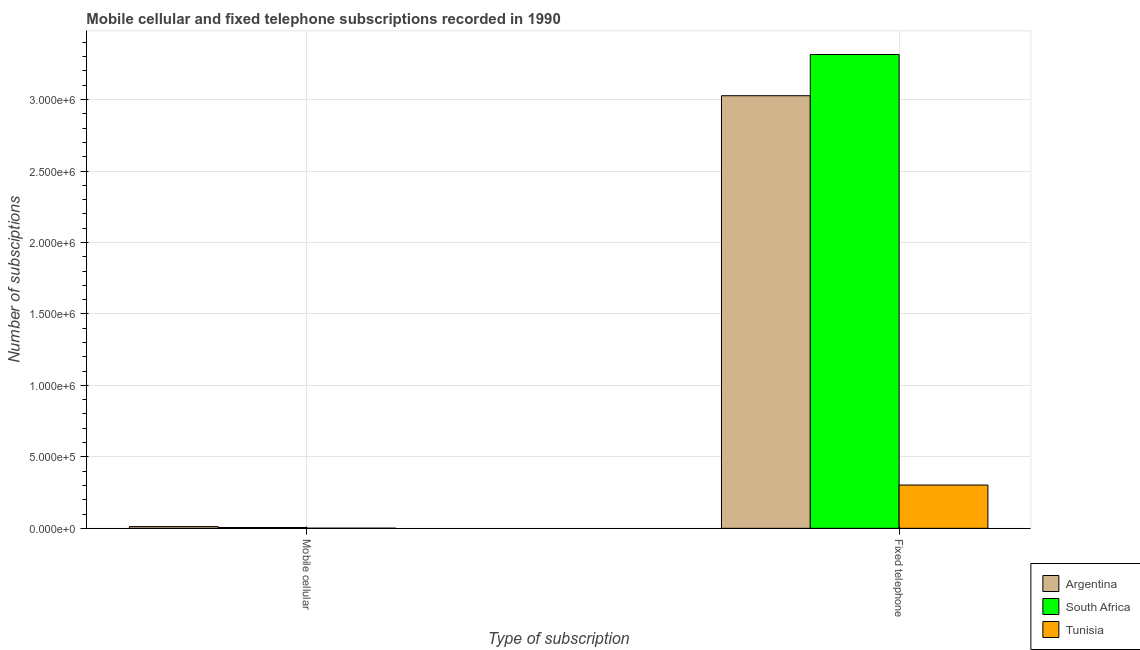How many groups of bars are there?
Provide a short and direct response. 2. How many bars are there on the 2nd tick from the right?
Give a very brief answer. 3. What is the label of the 1st group of bars from the left?
Offer a very short reply. Mobile cellular. What is the number of fixed telephone subscriptions in South Africa?
Offer a terse response. 3.32e+06. Across all countries, what is the maximum number of mobile cellular subscriptions?
Ensure brevity in your answer.  1.20e+04. Across all countries, what is the minimum number of fixed telephone subscriptions?
Provide a short and direct response. 3.03e+05. In which country was the number of mobile cellular subscriptions maximum?
Your answer should be very brief. Argentina. In which country was the number of mobile cellular subscriptions minimum?
Keep it short and to the point. Tunisia. What is the total number of fixed telephone subscriptions in the graph?
Make the answer very short. 6.64e+06. What is the difference between the number of fixed telephone subscriptions in Tunisia and that in South Africa?
Offer a terse response. -3.01e+06. What is the difference between the number of fixed telephone subscriptions in Argentina and the number of mobile cellular subscriptions in Tunisia?
Offer a very short reply. 3.03e+06. What is the average number of fixed telephone subscriptions per country?
Ensure brevity in your answer.  2.21e+06. What is the difference between the number of fixed telephone subscriptions and number of mobile cellular subscriptions in Argentina?
Ensure brevity in your answer.  3.01e+06. In how many countries, is the number of mobile cellular subscriptions greater than 700000 ?
Keep it short and to the point. 0. What is the ratio of the number of fixed telephone subscriptions in South Africa to that in Argentina?
Offer a very short reply. 1.1. Is the number of mobile cellular subscriptions in Tunisia less than that in South Africa?
Your answer should be very brief. Yes. What does the 1st bar from the left in Mobile cellular represents?
Ensure brevity in your answer.  Argentina. How many bars are there?
Give a very brief answer. 6. How many countries are there in the graph?
Provide a short and direct response. 3. What is the difference between two consecutive major ticks on the Y-axis?
Your answer should be compact. 5.00e+05. Where does the legend appear in the graph?
Your answer should be compact. Bottom right. How many legend labels are there?
Make the answer very short. 3. What is the title of the graph?
Give a very brief answer. Mobile cellular and fixed telephone subscriptions recorded in 1990. Does "Belize" appear as one of the legend labels in the graph?
Give a very brief answer. No. What is the label or title of the X-axis?
Provide a short and direct response. Type of subscription. What is the label or title of the Y-axis?
Your response must be concise. Number of subsciptions. What is the Number of subsciptions of Argentina in Mobile cellular?
Your answer should be compact. 1.20e+04. What is the Number of subsciptions in South Africa in Mobile cellular?
Offer a very short reply. 5680. What is the Number of subsciptions of Tunisia in Mobile cellular?
Provide a succinct answer. 953. What is the Number of subsciptions of Argentina in Fixed telephone?
Offer a terse response. 3.03e+06. What is the Number of subsciptions in South Africa in Fixed telephone?
Provide a short and direct response. 3.32e+06. What is the Number of subsciptions of Tunisia in Fixed telephone?
Offer a terse response. 3.03e+05. Across all Type of subscription, what is the maximum Number of subsciptions in Argentina?
Offer a very short reply. 3.03e+06. Across all Type of subscription, what is the maximum Number of subsciptions in South Africa?
Offer a very short reply. 3.32e+06. Across all Type of subscription, what is the maximum Number of subsciptions in Tunisia?
Provide a succinct answer. 3.03e+05. Across all Type of subscription, what is the minimum Number of subsciptions in Argentina?
Offer a terse response. 1.20e+04. Across all Type of subscription, what is the minimum Number of subsciptions in South Africa?
Provide a succinct answer. 5680. Across all Type of subscription, what is the minimum Number of subsciptions in Tunisia?
Give a very brief answer. 953. What is the total Number of subsciptions in Argentina in the graph?
Your answer should be compact. 3.04e+06. What is the total Number of subsciptions of South Africa in the graph?
Offer a terse response. 3.32e+06. What is the total Number of subsciptions of Tunisia in the graph?
Your answer should be very brief. 3.04e+05. What is the difference between the Number of subsciptions of Argentina in Mobile cellular and that in Fixed telephone?
Offer a very short reply. -3.01e+06. What is the difference between the Number of subsciptions of South Africa in Mobile cellular and that in Fixed telephone?
Offer a terse response. -3.31e+06. What is the difference between the Number of subsciptions in Tunisia in Mobile cellular and that in Fixed telephone?
Offer a very short reply. -3.02e+05. What is the difference between the Number of subsciptions in Argentina in Mobile cellular and the Number of subsciptions in South Africa in Fixed telephone?
Keep it short and to the point. -3.30e+06. What is the difference between the Number of subsciptions in Argentina in Mobile cellular and the Number of subsciptions in Tunisia in Fixed telephone?
Your response must be concise. -2.91e+05. What is the difference between the Number of subsciptions of South Africa in Mobile cellular and the Number of subsciptions of Tunisia in Fixed telephone?
Your answer should be very brief. -2.97e+05. What is the average Number of subsciptions in Argentina per Type of subscription?
Ensure brevity in your answer.  1.52e+06. What is the average Number of subsciptions of South Africa per Type of subscription?
Ensure brevity in your answer.  1.66e+06. What is the average Number of subsciptions of Tunisia per Type of subscription?
Offer a terse response. 1.52e+05. What is the difference between the Number of subsciptions of Argentina and Number of subsciptions of South Africa in Mobile cellular?
Keep it short and to the point. 6320. What is the difference between the Number of subsciptions of Argentina and Number of subsciptions of Tunisia in Mobile cellular?
Your answer should be compact. 1.10e+04. What is the difference between the Number of subsciptions of South Africa and Number of subsciptions of Tunisia in Mobile cellular?
Offer a terse response. 4727. What is the difference between the Number of subsciptions in Argentina and Number of subsciptions in South Africa in Fixed telephone?
Offer a very short reply. -2.88e+05. What is the difference between the Number of subsciptions in Argentina and Number of subsciptions in Tunisia in Fixed telephone?
Provide a succinct answer. 2.72e+06. What is the difference between the Number of subsciptions in South Africa and Number of subsciptions in Tunisia in Fixed telephone?
Keep it short and to the point. 3.01e+06. What is the ratio of the Number of subsciptions in Argentina in Mobile cellular to that in Fixed telephone?
Your answer should be compact. 0. What is the ratio of the Number of subsciptions in South Africa in Mobile cellular to that in Fixed telephone?
Ensure brevity in your answer.  0. What is the ratio of the Number of subsciptions in Tunisia in Mobile cellular to that in Fixed telephone?
Your response must be concise. 0. What is the difference between the highest and the second highest Number of subsciptions of Argentina?
Your answer should be compact. 3.01e+06. What is the difference between the highest and the second highest Number of subsciptions of South Africa?
Make the answer very short. 3.31e+06. What is the difference between the highest and the second highest Number of subsciptions of Tunisia?
Give a very brief answer. 3.02e+05. What is the difference between the highest and the lowest Number of subsciptions in Argentina?
Provide a short and direct response. 3.01e+06. What is the difference between the highest and the lowest Number of subsciptions in South Africa?
Make the answer very short. 3.31e+06. What is the difference between the highest and the lowest Number of subsciptions of Tunisia?
Your answer should be very brief. 3.02e+05. 